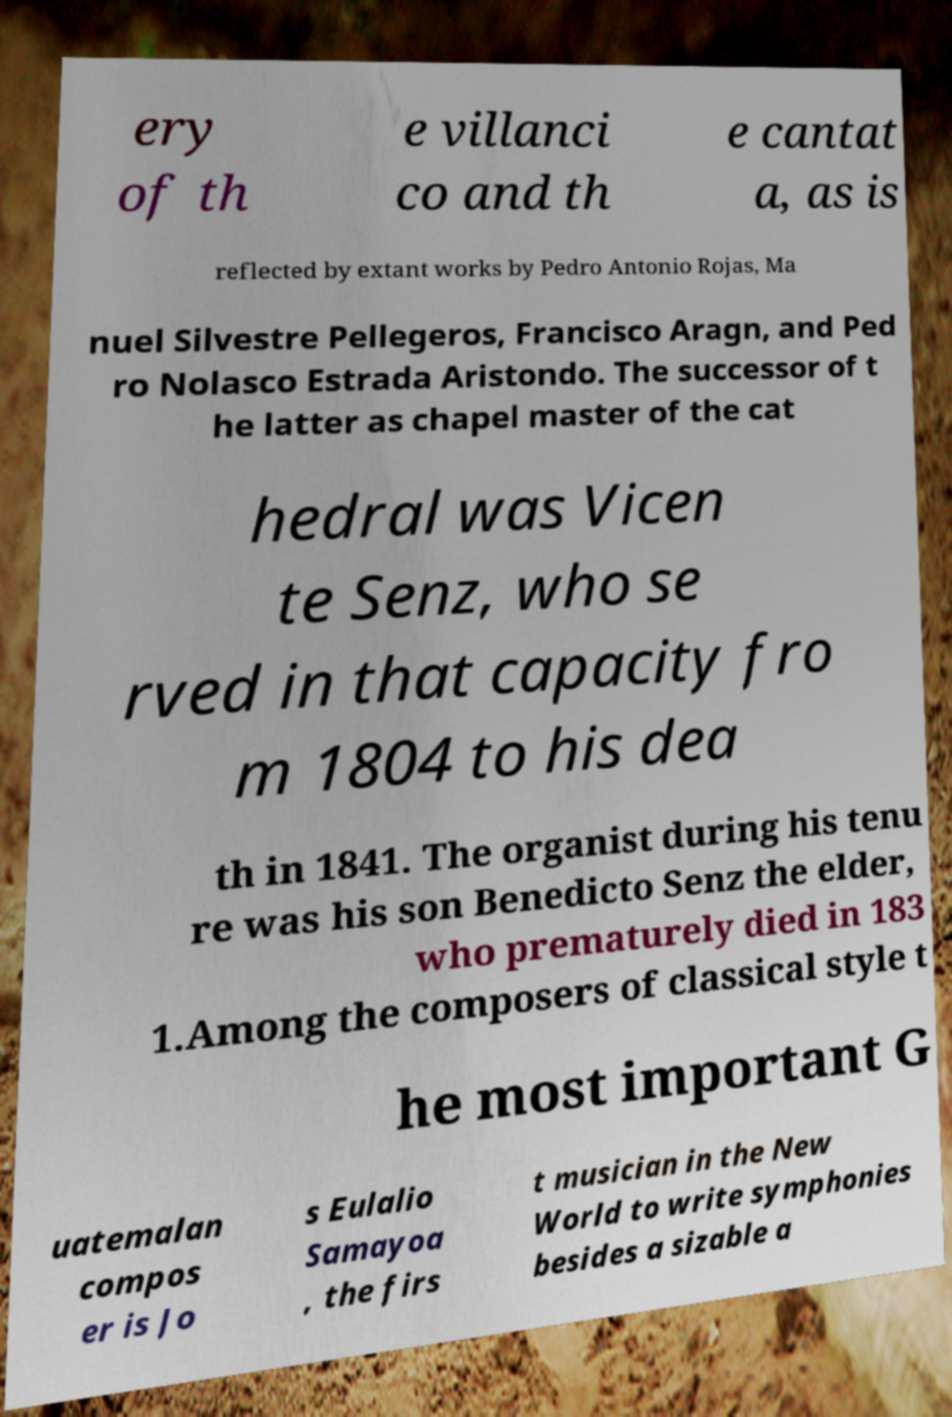Could you extract and type out the text from this image? ery of th e villanci co and th e cantat a, as is reflected by extant works by Pedro Antonio Rojas, Ma nuel Silvestre Pellegeros, Francisco Aragn, and Ped ro Nolasco Estrada Aristondo. The successor of t he latter as chapel master of the cat hedral was Vicen te Senz, who se rved in that capacity fro m 1804 to his dea th in 1841. The organist during his tenu re was his son Benedicto Senz the elder, who prematurely died in 183 1.Among the composers of classical style t he most important G uatemalan compos er is Jo s Eulalio Samayoa , the firs t musician in the New World to write symphonies besides a sizable a 